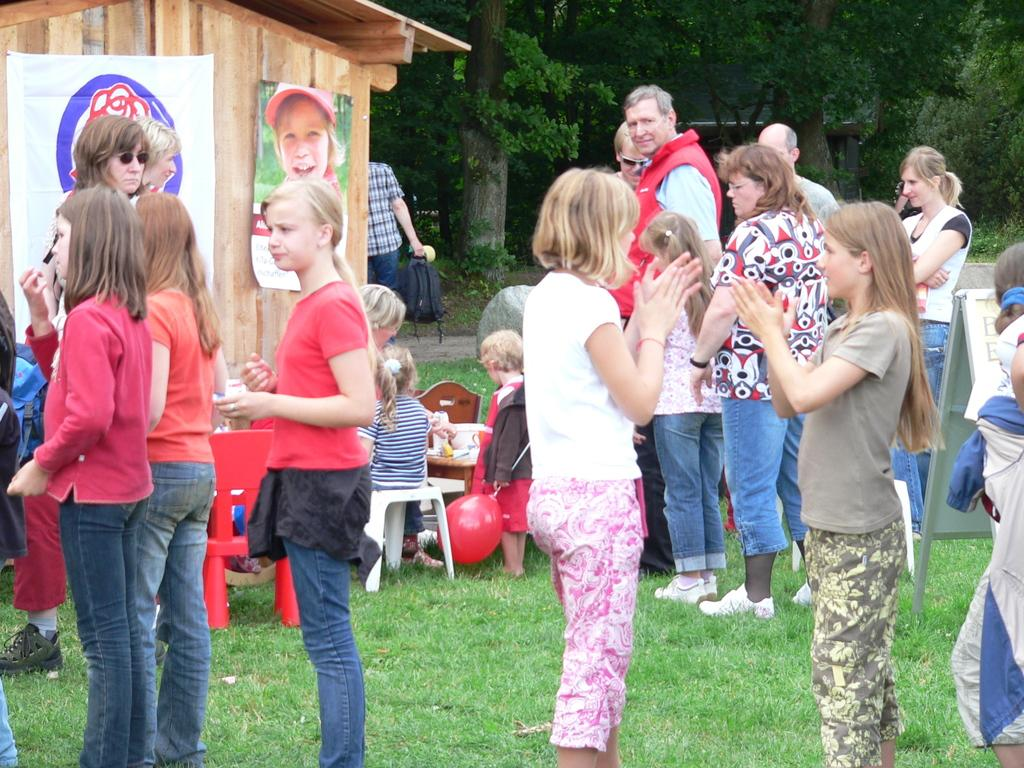How many people are in the image? There is a group of people in the image, but the exact number is not specified. What is the surface the people are standing on? The people are standing on grass in the image. What type of furniture is present in the image? There are chairs in the image. What decorative item can be seen in the image? There is a balloon in the image. What is hanging on the wall in the image? There are banners on the wall in the image. What can be seen in the background of the image? Trees are visible in the background of the image. What type of straw is used to extract resources from the mine in the image? There is no mine or straw present in the image; it features a group of people standing on grass with chairs, a balloon, banners, and trees in the background. 